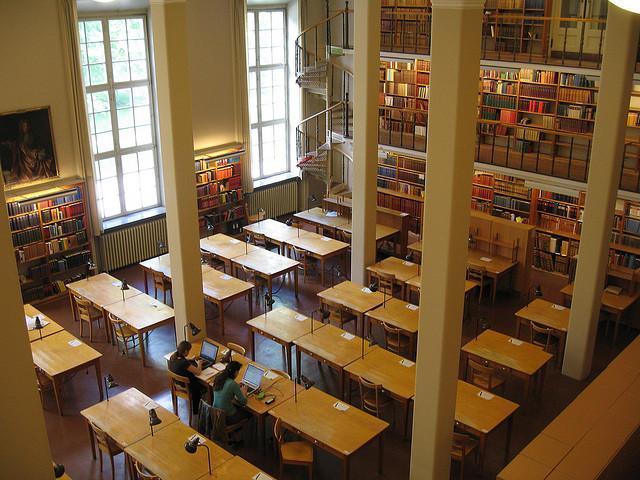How many dining tables are there?
Give a very brief answer. 3. How many pieces of cake is in the photo?
Give a very brief answer. 0. 